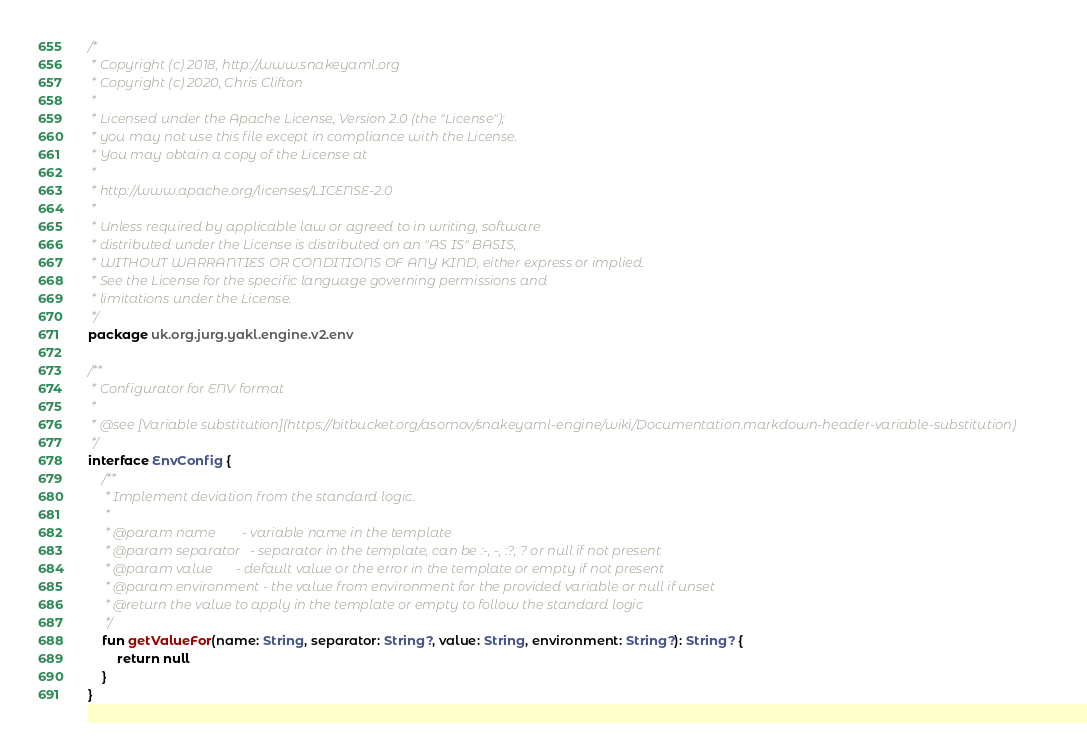Convert code to text. <code><loc_0><loc_0><loc_500><loc_500><_Kotlin_>/*
 * Copyright (c) 2018, http://www.snakeyaml.org
 * Copyright (c) 2020, Chris Clifton
 *
 * Licensed under the Apache License, Version 2.0 (the "License");
 * you may not use this file except in compliance with the License.
 * You may obtain a copy of the License at
 *
 * http://www.apache.org/licenses/LICENSE-2.0
 *
 * Unless required by applicable law or agreed to in writing, software
 * distributed under the License is distributed on an "AS IS" BASIS,
 * WITHOUT WARRANTIES OR CONDITIONS OF ANY KIND, either express or implied.
 * See the License for the specific language governing permissions and
 * limitations under the License.
 */
package uk.org.jurg.yakl.engine.v2.env

/**
 * Configurator for ENV format
 *
 * @see [Variable substitution](https://bitbucket.org/asomov/snakeyaml-engine/wiki/Documentation.markdown-header-variable-substitution)
 */
interface EnvConfig {
    /**
     * Implement deviation from the standard logic.
     *
     * @param name        - variable name in the template
     * @param separator   - separator in the template, can be :-, -, :?, ? or null if not present
     * @param value       - default value or the error in the template or empty if not present
     * @param environment - the value from environment for the provided variable or null if unset
     * @return the value to apply in the template or empty to follow the standard logic
     */
    fun getValueFor(name: String, separator: String?, value: String, environment: String?): String? {
        return null
    }
}
</code> 